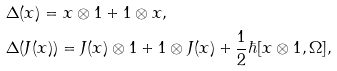<formula> <loc_0><loc_0><loc_500><loc_500>& \Delta ( x ) = x \otimes 1 + 1 \otimes x , \\ & \Delta ( J ( x ) ) = J ( x ) \otimes 1 + 1 \otimes J ( x ) + \frac { 1 } { 2 } \hbar { [ } x \otimes 1 , \Omega ] ,</formula> 